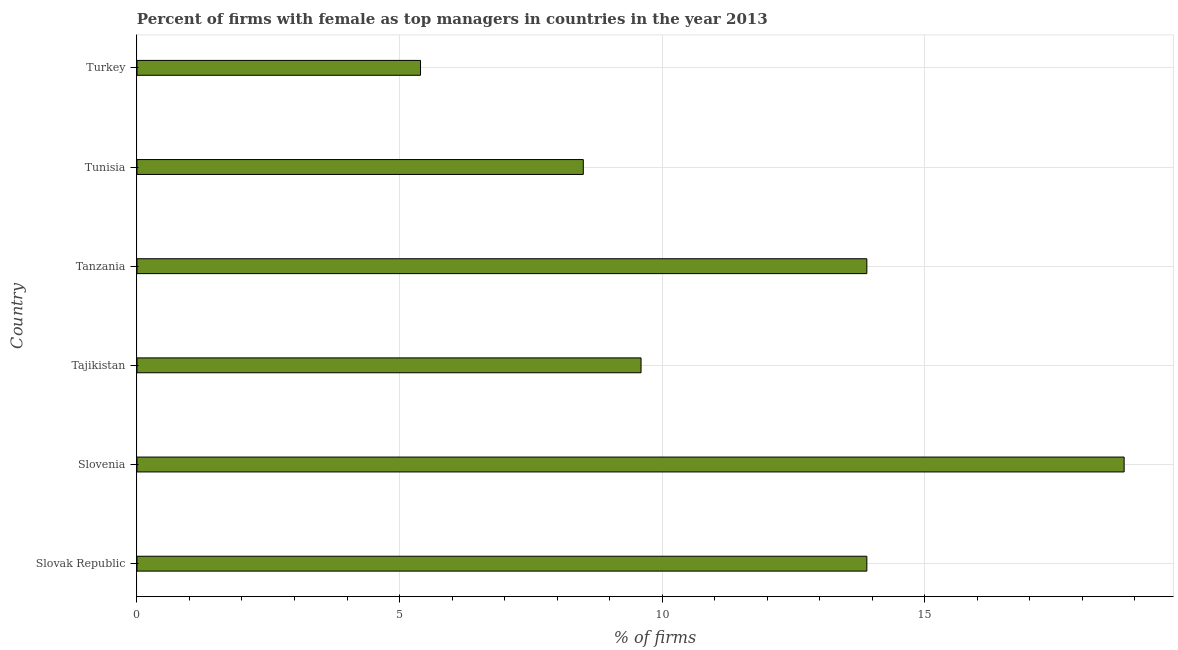Does the graph contain grids?
Your response must be concise. Yes. What is the title of the graph?
Your answer should be very brief. Percent of firms with female as top managers in countries in the year 2013. What is the label or title of the X-axis?
Offer a terse response. % of firms. Across all countries, what is the minimum percentage of firms with female as top manager?
Keep it short and to the point. 5.4. In which country was the percentage of firms with female as top manager maximum?
Make the answer very short. Slovenia. In which country was the percentage of firms with female as top manager minimum?
Provide a succinct answer. Turkey. What is the sum of the percentage of firms with female as top manager?
Your answer should be very brief. 70.1. What is the average percentage of firms with female as top manager per country?
Ensure brevity in your answer.  11.68. What is the median percentage of firms with female as top manager?
Keep it short and to the point. 11.75. What is the ratio of the percentage of firms with female as top manager in Slovenia to that in Tajikistan?
Give a very brief answer. 1.96. Is the percentage of firms with female as top manager in Slovenia less than that in Tanzania?
Ensure brevity in your answer.  No. What is the difference between the highest and the lowest percentage of firms with female as top manager?
Ensure brevity in your answer.  13.4. How many bars are there?
Give a very brief answer. 6. Are the values on the major ticks of X-axis written in scientific E-notation?
Your answer should be very brief. No. What is the % of firms in Slovenia?
Your response must be concise. 18.8. What is the % of firms of Tanzania?
Provide a short and direct response. 13.9. What is the % of firms of Tunisia?
Your answer should be compact. 8.5. What is the % of firms in Turkey?
Offer a terse response. 5.4. What is the difference between the % of firms in Slovak Republic and Slovenia?
Your response must be concise. -4.9. What is the difference between the % of firms in Slovak Republic and Tanzania?
Your answer should be compact. 0. What is the difference between the % of firms in Slovenia and Tajikistan?
Ensure brevity in your answer.  9.2. What is the difference between the % of firms in Slovenia and Tanzania?
Offer a very short reply. 4.9. What is the difference between the % of firms in Slovenia and Tunisia?
Offer a very short reply. 10.3. What is the difference between the % of firms in Tajikistan and Turkey?
Your answer should be compact. 4.2. What is the difference between the % of firms in Tanzania and Tunisia?
Make the answer very short. 5.4. What is the difference between the % of firms in Tunisia and Turkey?
Give a very brief answer. 3.1. What is the ratio of the % of firms in Slovak Republic to that in Slovenia?
Give a very brief answer. 0.74. What is the ratio of the % of firms in Slovak Republic to that in Tajikistan?
Keep it short and to the point. 1.45. What is the ratio of the % of firms in Slovak Republic to that in Tanzania?
Keep it short and to the point. 1. What is the ratio of the % of firms in Slovak Republic to that in Tunisia?
Give a very brief answer. 1.64. What is the ratio of the % of firms in Slovak Republic to that in Turkey?
Offer a terse response. 2.57. What is the ratio of the % of firms in Slovenia to that in Tajikistan?
Keep it short and to the point. 1.96. What is the ratio of the % of firms in Slovenia to that in Tanzania?
Offer a terse response. 1.35. What is the ratio of the % of firms in Slovenia to that in Tunisia?
Make the answer very short. 2.21. What is the ratio of the % of firms in Slovenia to that in Turkey?
Give a very brief answer. 3.48. What is the ratio of the % of firms in Tajikistan to that in Tanzania?
Your answer should be very brief. 0.69. What is the ratio of the % of firms in Tajikistan to that in Tunisia?
Ensure brevity in your answer.  1.13. What is the ratio of the % of firms in Tajikistan to that in Turkey?
Provide a succinct answer. 1.78. What is the ratio of the % of firms in Tanzania to that in Tunisia?
Your response must be concise. 1.64. What is the ratio of the % of firms in Tanzania to that in Turkey?
Provide a short and direct response. 2.57. What is the ratio of the % of firms in Tunisia to that in Turkey?
Provide a short and direct response. 1.57. 